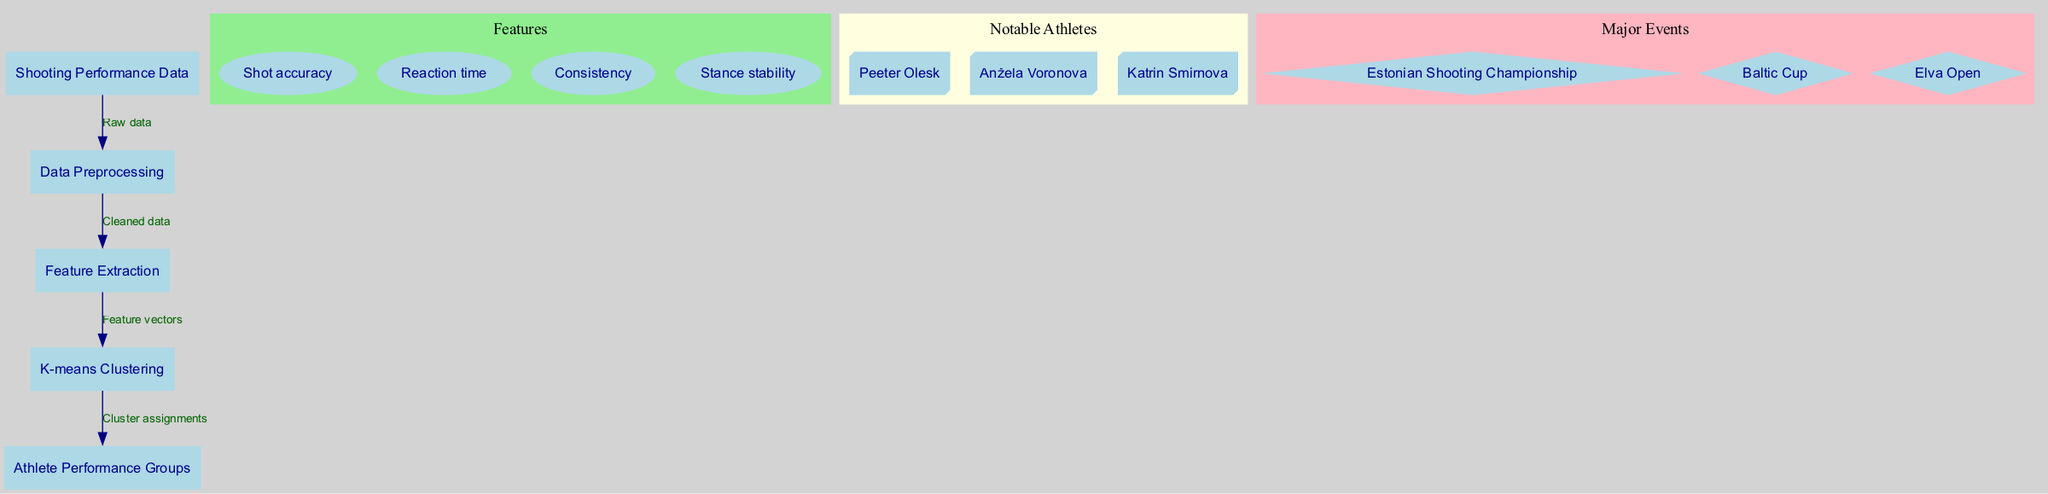what is the total number of nodes in the diagram? The diagram contains five nodes: 'Shooting Performance Data', 'Data Preprocessing', 'Feature Extraction', 'K-means Clustering', and 'Athlete Performance Groups'. Counting all of these gives a total of five nodes.
Answer: 5 how many edges connect the nodes in the diagram? The diagram has four edges: 'Raw data' connecting 'Shooting Performance Data' to 'Data Preprocessing', 'Cleaned data' connecting 'Data Preprocessing' to 'Feature Extraction', 'Feature vectors' connecting 'Feature Extraction' to 'K-means Clustering', and 'Cluster assignments' connecting 'K-means Clustering' to 'Athlete Performance Groups'. Counting these gives a total of four edges.
Answer: 4 which node outputs the clusters? The 'K-means Clustering' node outputs the cluster assignments which are then sent to the 'Athlete Performance Groups' node. Thus, the node that directly outputs the clusters is 'K-means Clustering'.
Answer: K-means Clustering what type of data is processed first in the diagram? The first type of data is 'Shooting Performance Data', which is the raw input data processed by the diagram before any other steps occur. This begins the data flow.
Answer: Shooting Performance Data what is the relationship between 'Feature Extraction' and 'K-means Clustering'? The relationship is that 'Feature Extraction' provides 'Feature vectors' to 'K-means Clustering', enabling the clustering process to categorize athletes based on their performance patterns.
Answer: Feature vectors which feature is related to consistency in shooting performance? The feature 'Consistency' directly represents the measurement related to athletes' consistency in shooting performance, outlined as one of the key features in the diagram.
Answer: Consistency how many notable athletes are listed in the diagram? There are three notable athletes listed: 'Peeter Olesk', 'Anžela Voronova', and 'Katrin Smirnova'. Counting these gives a total of three athletes.
Answer: 3 what major event is included in the diagram related to shooting sports? The diagram lists 'Estonian Shooting Championship' as one of the major events associated with shooting sports. This event is highlighted as a significant occasion for athletes.
Answer: Estonian Shooting Championship what is the color of the nodes representing major events? The nodes representing major events are filled with a light pink color, as indicated by the graph attributes set for that specific subgraph.
Answer: light pink 